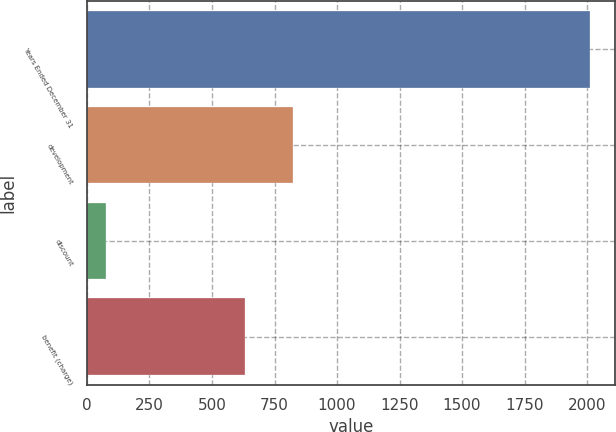<chart> <loc_0><loc_0><loc_500><loc_500><bar_chart><fcel>Years Ended December 31<fcel>development<fcel>discount<fcel>benefit (charge)<nl><fcel>2013<fcel>824.7<fcel>76<fcel>631<nl></chart> 